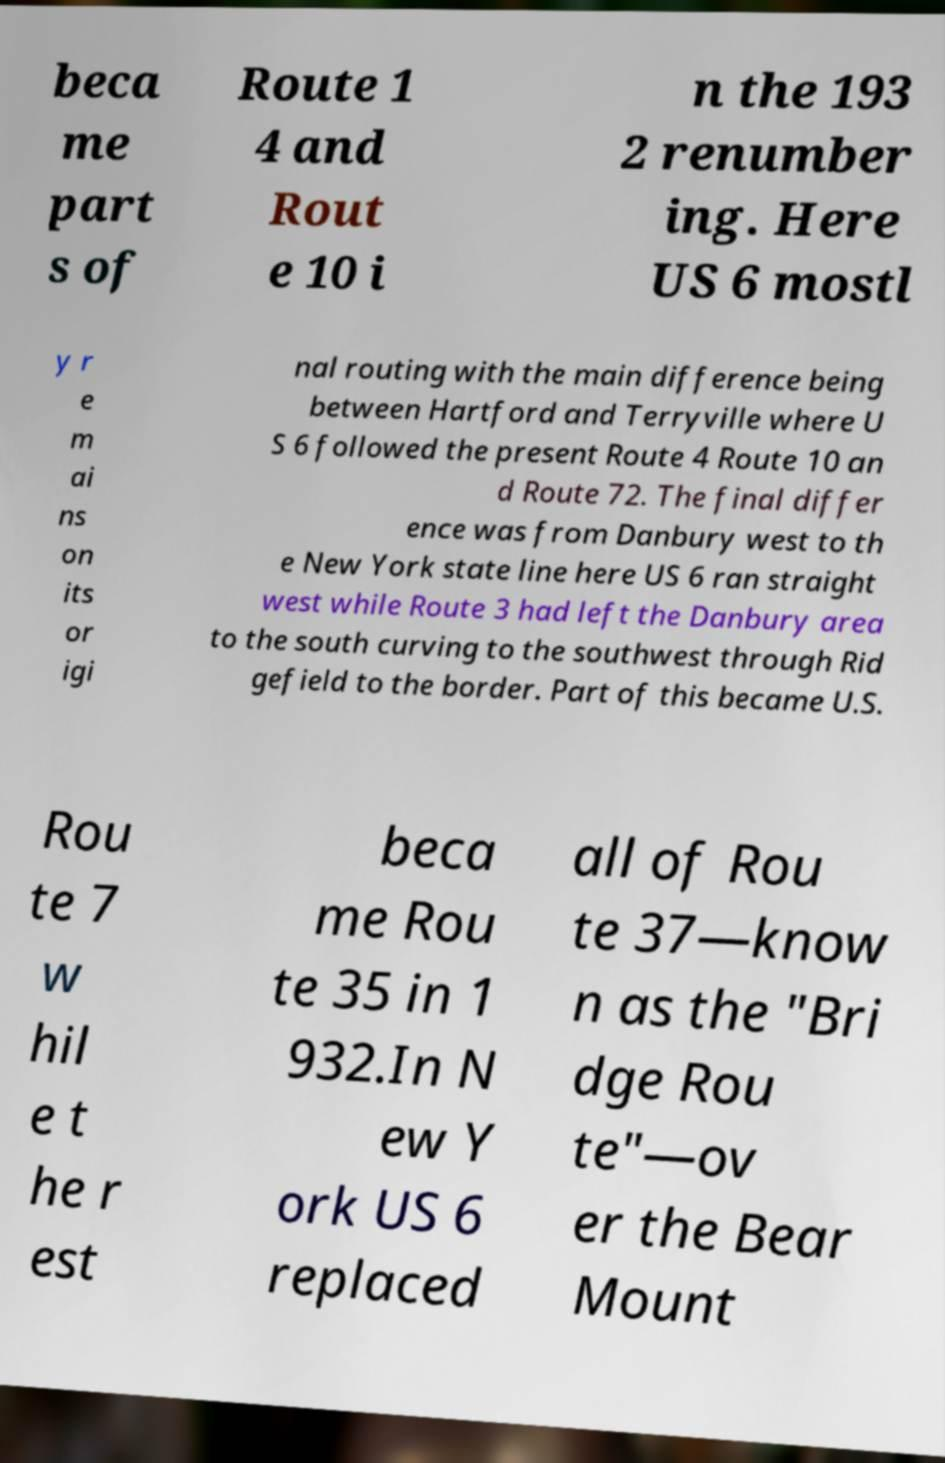For documentation purposes, I need the text within this image transcribed. Could you provide that? beca me part s of Route 1 4 and Rout e 10 i n the 193 2 renumber ing. Here US 6 mostl y r e m ai ns on its or igi nal routing with the main difference being between Hartford and Terryville where U S 6 followed the present Route 4 Route 10 an d Route 72. The final differ ence was from Danbury west to th e New York state line here US 6 ran straight west while Route 3 had left the Danbury area to the south curving to the southwest through Rid gefield to the border. Part of this became U.S. Rou te 7 w hil e t he r est beca me Rou te 35 in 1 932.In N ew Y ork US 6 replaced all of Rou te 37—know n as the "Bri dge Rou te"—ov er the Bear Mount 